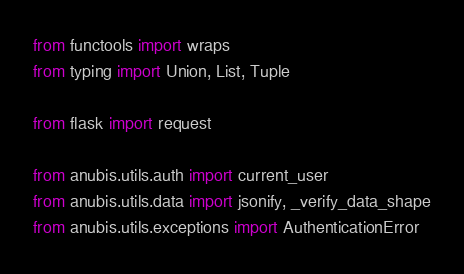Convert code to text. <code><loc_0><loc_0><loc_500><loc_500><_Python_>from functools import wraps
from typing import Union, List, Tuple

from flask import request

from anubis.utils.auth import current_user
from anubis.utils.data import jsonify, _verify_data_shape
from anubis.utils.exceptions import AuthenticationError</code> 